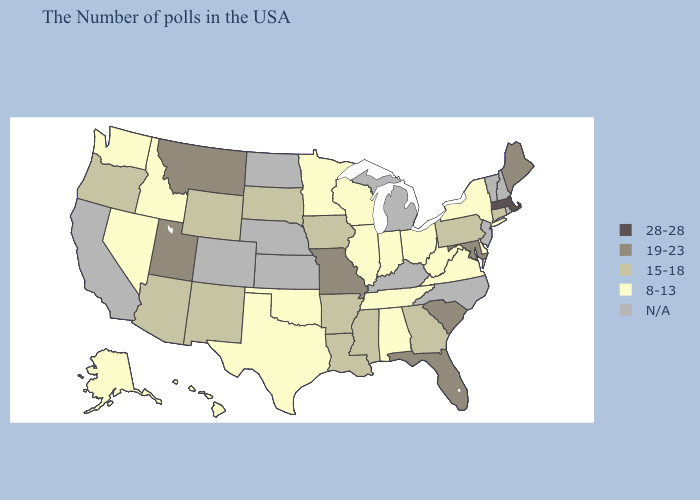Among the states that border Wisconsin , does Iowa have the lowest value?
Short answer required. No. What is the highest value in the MidWest ?
Quick response, please. 19-23. Does New York have the lowest value in the Northeast?
Be succinct. Yes. Name the states that have a value in the range 28-28?
Give a very brief answer. Massachusetts. Does Iowa have the lowest value in the USA?
Give a very brief answer. No. What is the lowest value in the USA?
Give a very brief answer. 8-13. Which states have the lowest value in the Northeast?
Write a very short answer. New York. Which states have the highest value in the USA?
Be succinct. Massachusetts. Among the states that border Nebraska , does Wyoming have the highest value?
Write a very short answer. No. Name the states that have a value in the range 28-28?
Write a very short answer. Massachusetts. Name the states that have a value in the range N/A?
Write a very short answer. Rhode Island, New Hampshire, Vermont, New Jersey, North Carolina, Michigan, Kentucky, Kansas, Nebraska, North Dakota, Colorado, California. What is the highest value in the MidWest ?
Short answer required. 19-23. What is the highest value in the West ?
Quick response, please. 19-23. What is the value of Michigan?
Keep it brief. N/A. What is the highest value in states that border Mississippi?
Give a very brief answer. 15-18. 